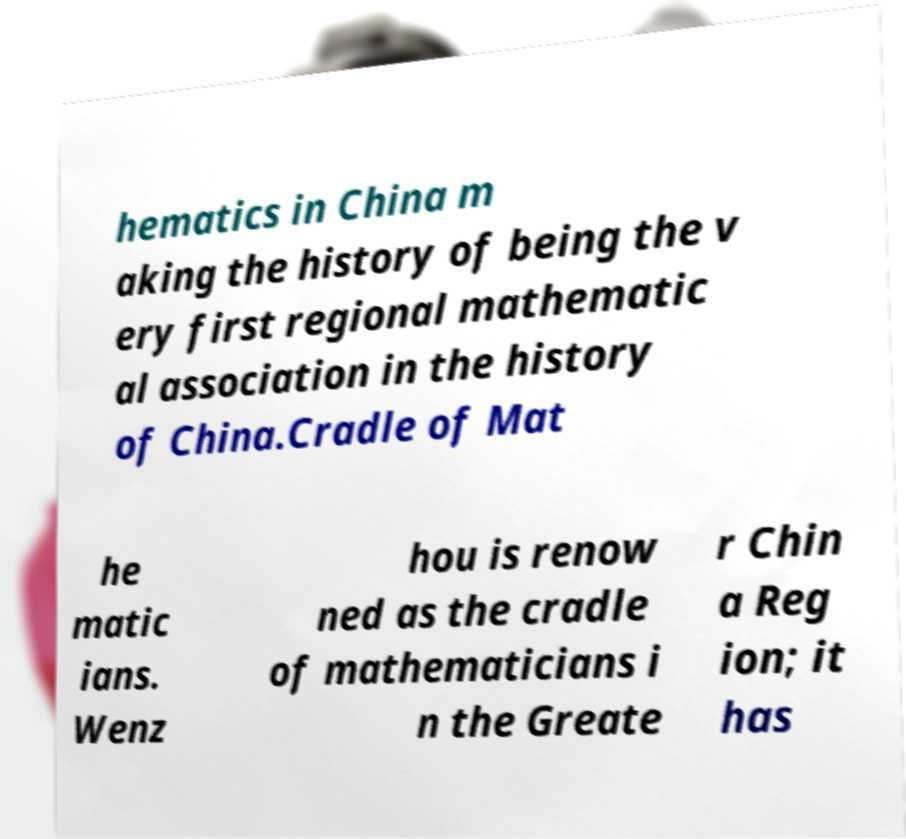I need the written content from this picture converted into text. Can you do that? hematics in China m aking the history of being the v ery first regional mathematic al association in the history of China.Cradle of Mat he matic ians. Wenz hou is renow ned as the cradle of mathematicians i n the Greate r Chin a Reg ion; it has 